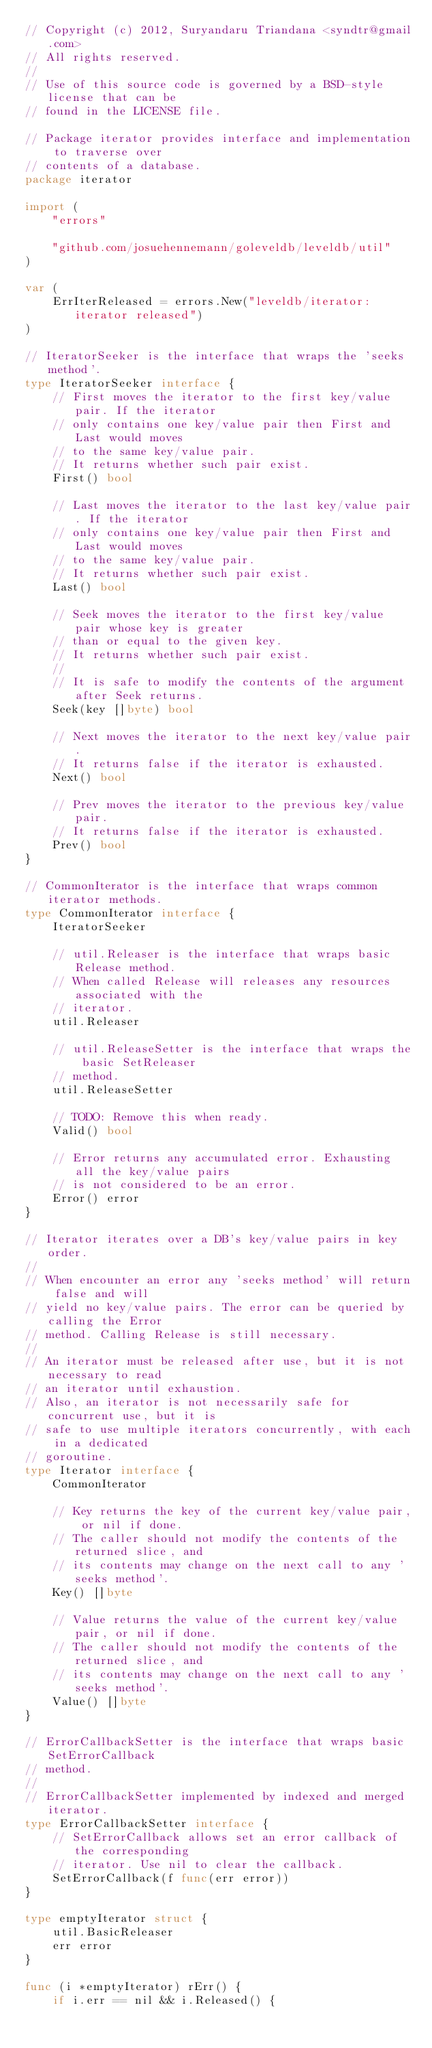<code> <loc_0><loc_0><loc_500><loc_500><_Go_>// Copyright (c) 2012, Suryandaru Triandana <syndtr@gmail.com>
// All rights reserved.
//
// Use of this source code is governed by a BSD-style license that can be
// found in the LICENSE file.

// Package iterator provides interface and implementation to traverse over
// contents of a database.
package iterator

import (
	"errors"

	"github.com/josuehennemann/goleveldb/leveldb/util"
)

var (
	ErrIterReleased = errors.New("leveldb/iterator: iterator released")
)

// IteratorSeeker is the interface that wraps the 'seeks method'.
type IteratorSeeker interface {
	// First moves the iterator to the first key/value pair. If the iterator
	// only contains one key/value pair then First and Last would moves
	// to the same key/value pair.
	// It returns whether such pair exist.
	First() bool

	// Last moves the iterator to the last key/value pair. If the iterator
	// only contains one key/value pair then First and Last would moves
	// to the same key/value pair.
	// It returns whether such pair exist.
	Last() bool

	// Seek moves the iterator to the first key/value pair whose key is greater
	// than or equal to the given key.
	// It returns whether such pair exist.
	//
	// It is safe to modify the contents of the argument after Seek returns.
	Seek(key []byte) bool

	// Next moves the iterator to the next key/value pair.
	// It returns false if the iterator is exhausted.
	Next() bool

	// Prev moves the iterator to the previous key/value pair.
	// It returns false if the iterator is exhausted.
	Prev() bool
}

// CommonIterator is the interface that wraps common iterator methods.
type CommonIterator interface {
	IteratorSeeker

	// util.Releaser is the interface that wraps basic Release method.
	// When called Release will releases any resources associated with the
	// iterator.
	util.Releaser

	// util.ReleaseSetter is the interface that wraps the basic SetReleaser
	// method.
	util.ReleaseSetter

	// TODO: Remove this when ready.
	Valid() bool

	// Error returns any accumulated error. Exhausting all the key/value pairs
	// is not considered to be an error.
	Error() error
}

// Iterator iterates over a DB's key/value pairs in key order.
//
// When encounter an error any 'seeks method' will return false and will
// yield no key/value pairs. The error can be queried by calling the Error
// method. Calling Release is still necessary.
//
// An iterator must be released after use, but it is not necessary to read
// an iterator until exhaustion.
// Also, an iterator is not necessarily safe for concurrent use, but it is
// safe to use multiple iterators concurrently, with each in a dedicated
// goroutine.
type Iterator interface {
	CommonIterator

	// Key returns the key of the current key/value pair, or nil if done.
	// The caller should not modify the contents of the returned slice, and
	// its contents may change on the next call to any 'seeks method'.
	Key() []byte

	// Value returns the value of the current key/value pair, or nil if done.
	// The caller should not modify the contents of the returned slice, and
	// its contents may change on the next call to any 'seeks method'.
	Value() []byte
}

// ErrorCallbackSetter is the interface that wraps basic SetErrorCallback
// method.
//
// ErrorCallbackSetter implemented by indexed and merged iterator.
type ErrorCallbackSetter interface {
	// SetErrorCallback allows set an error callback of the corresponding
	// iterator. Use nil to clear the callback.
	SetErrorCallback(f func(err error))
}

type emptyIterator struct {
	util.BasicReleaser
	err error
}

func (i *emptyIterator) rErr() {
	if i.err == nil && i.Released() {</code> 